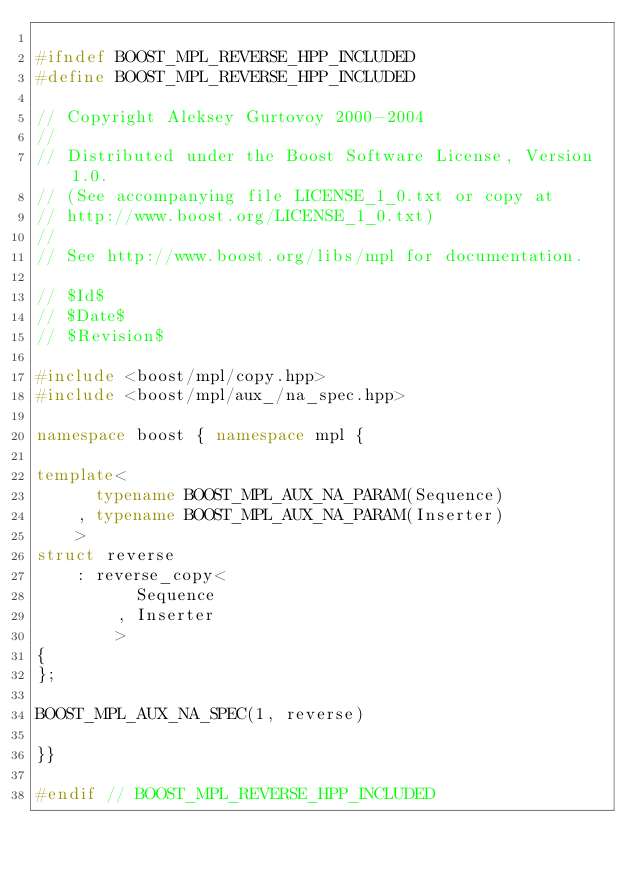Convert code to text. <code><loc_0><loc_0><loc_500><loc_500><_C++_>
#ifndef BOOST_MPL_REVERSE_HPP_INCLUDED
#define BOOST_MPL_REVERSE_HPP_INCLUDED

// Copyright Aleksey Gurtovoy 2000-2004
//
// Distributed under the Boost Software License, Version 1.0. 
// (See accompanying file LICENSE_1_0.txt or copy at 
// http://www.boost.org/LICENSE_1_0.txt)
//
// See http://www.boost.org/libs/mpl for documentation.

// $Id$
// $Date$
// $Revision$

#include <boost/mpl/copy.hpp>
#include <boost/mpl/aux_/na_spec.hpp>

namespace boost { namespace mpl {

template<
      typename BOOST_MPL_AUX_NA_PARAM(Sequence)
    , typename BOOST_MPL_AUX_NA_PARAM(Inserter)
    >
struct reverse
    : reverse_copy<
          Sequence
        , Inserter
        >
{
};

BOOST_MPL_AUX_NA_SPEC(1, reverse)

}}

#endif // BOOST_MPL_REVERSE_HPP_INCLUDED
</code> 